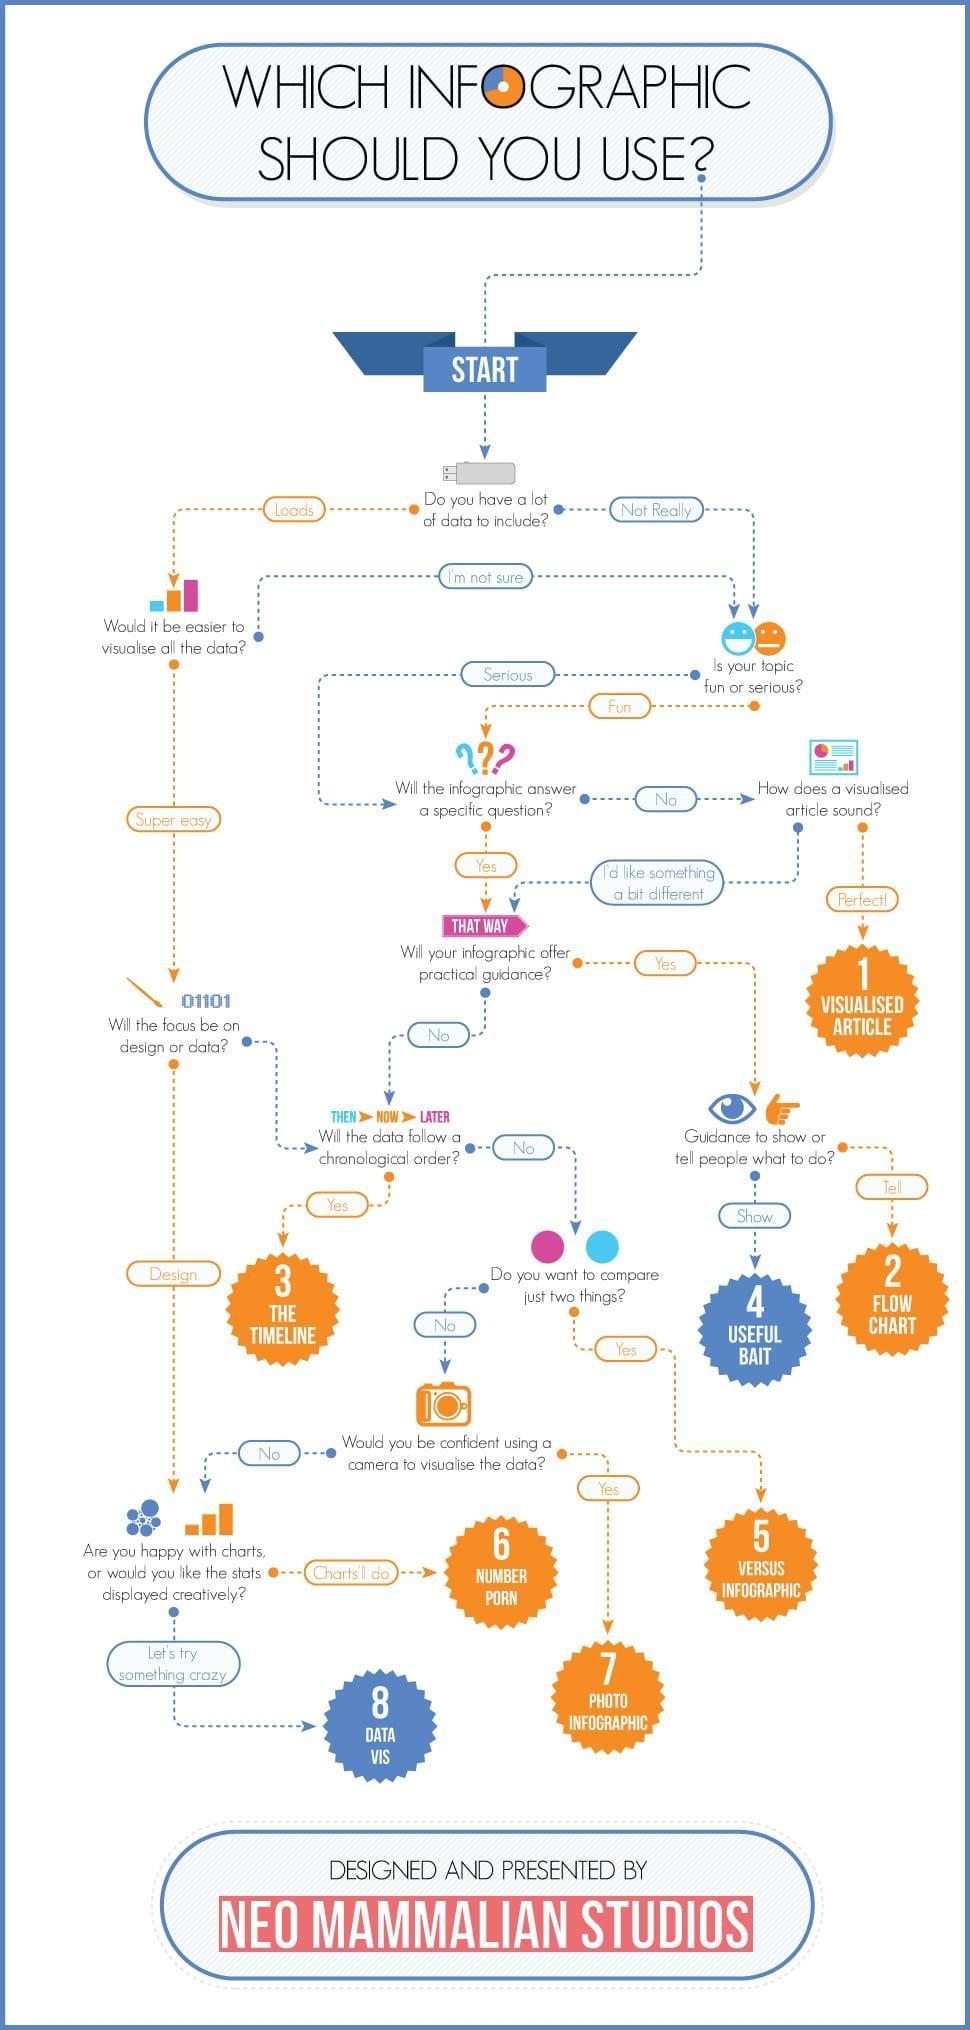Which form should the data be represented if it is meant to instruct people, Flow Chart, Timeline, or Useful Bait?
Answer the question with a short phrase. Flow chart How should the data be represented if it has chronology, flow chart, timeline, or photo infographic? timeline What would be solution if infographic is not what is required? Visualised Article 